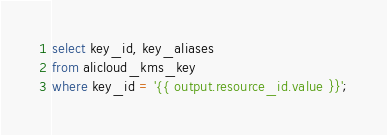<code> <loc_0><loc_0><loc_500><loc_500><_SQL_>select key_id, key_aliases
from alicloud_kms_key
where key_id = '{{ output.resource_id.value }}';</code> 